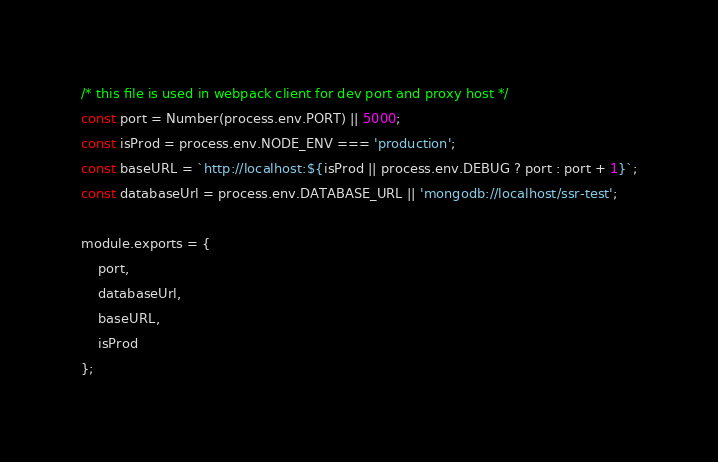Convert code to text. <code><loc_0><loc_0><loc_500><loc_500><_JavaScript_>/* this file is used in webpack client for dev port and proxy host */
const port = Number(process.env.PORT) || 5000;
const isProd = process.env.NODE_ENV === 'production';
const baseURL = `http://localhost:${isProd || process.env.DEBUG ? port : port + 1}`;
const databaseUrl = process.env.DATABASE_URL || 'mongodb://localhost/ssr-test';

module.exports = {
    port,
    databaseUrl,
    baseURL,
    isProd
};
</code> 